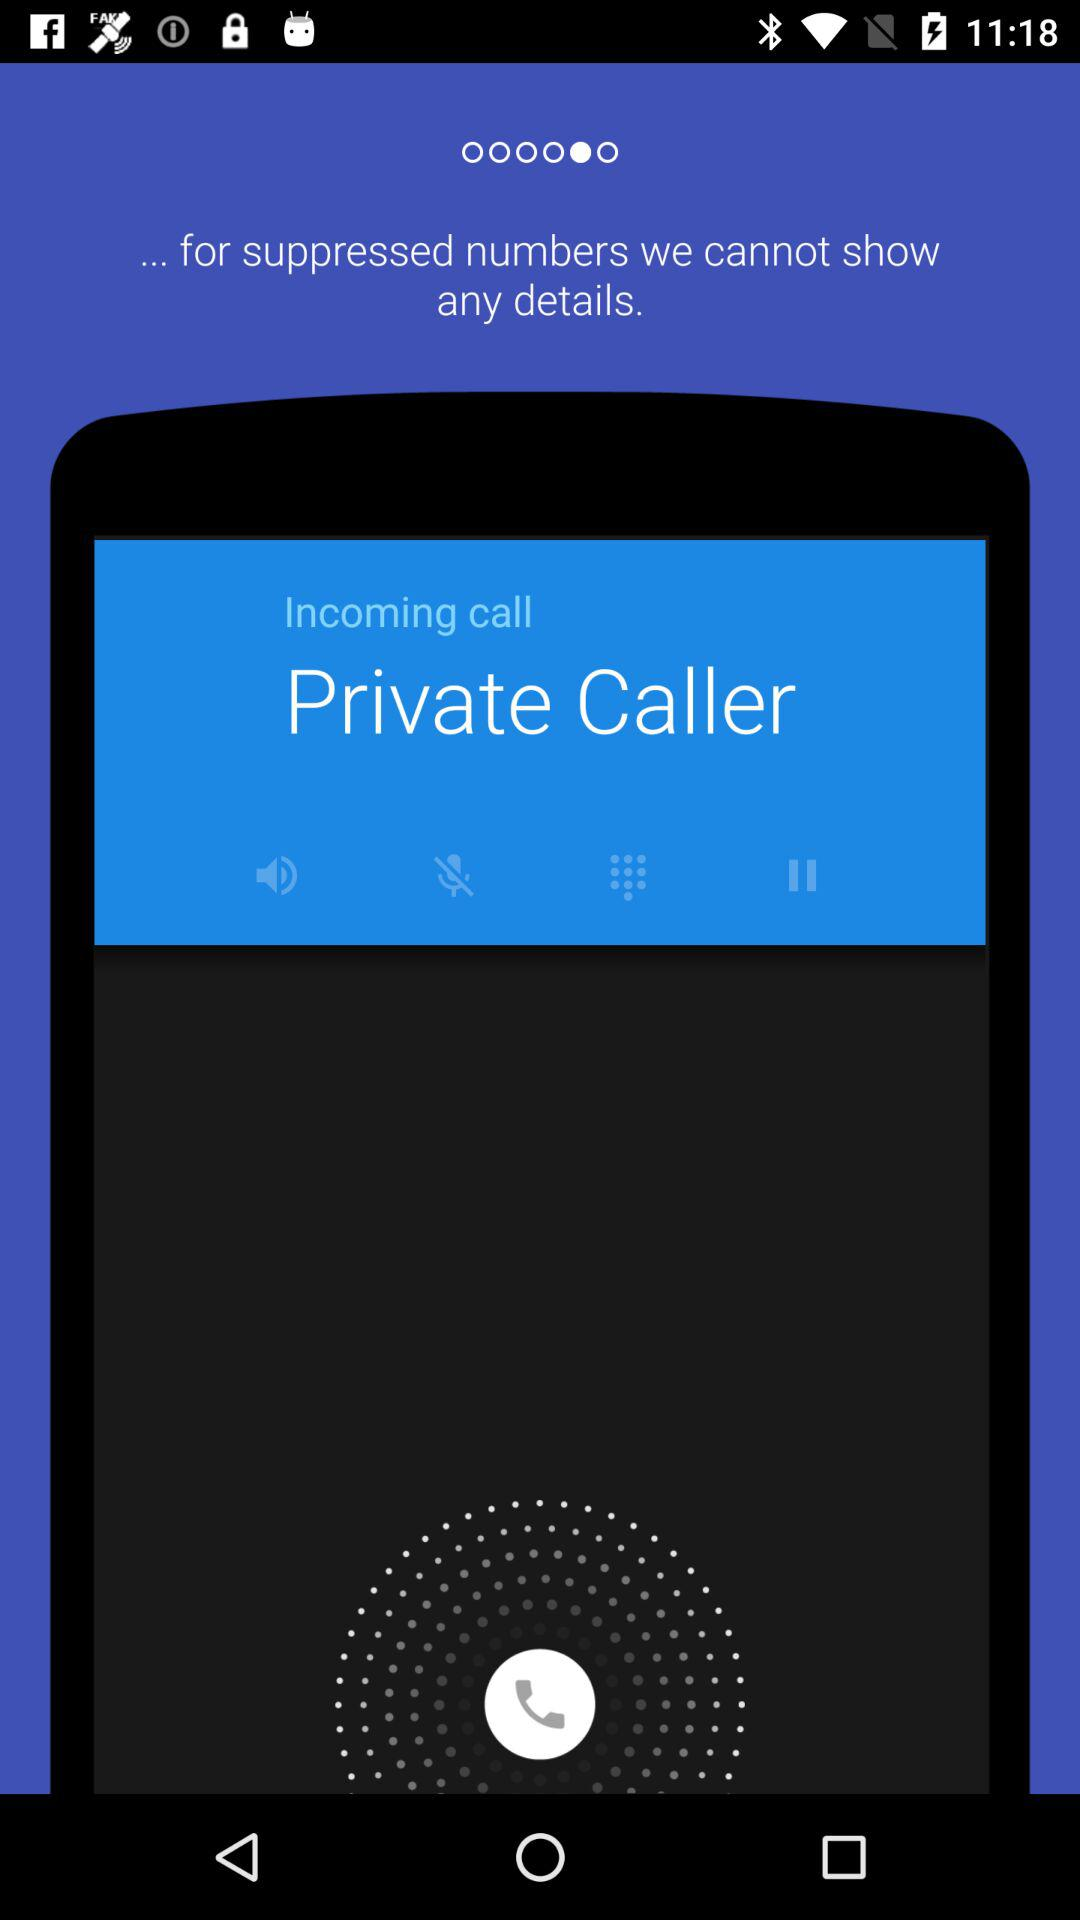What type of caller is calling? The type of caller is "Private". 